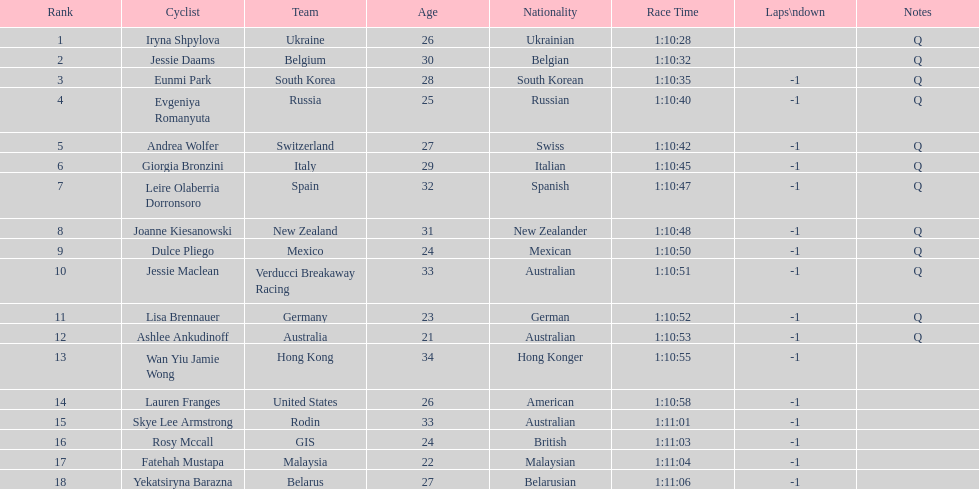Who was the first competitor to finish the race a lap behind? Eunmi Park. 